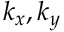Convert formula to latex. <formula><loc_0><loc_0><loc_500><loc_500>k _ { x } , k _ { y }</formula> 